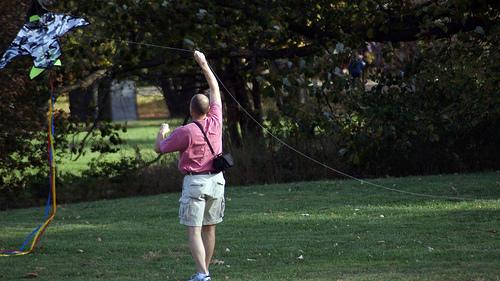What is the woman doing?
Give a very brief answer. Flying kite. Is the man athletic?
Quick response, please. Yes. What happened to the man's kite?
Keep it brief. Fell. What is the man doing?
Keep it brief. Flying kite. Is this a family game?
Give a very brief answer. No. What is he carrying on his back?
Concise answer only. Camera. What type of sport are they playing?
Concise answer only. Kite. 